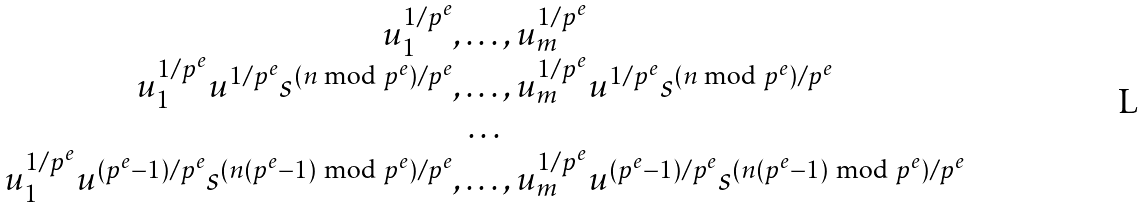Convert formula to latex. <formula><loc_0><loc_0><loc_500><loc_500>\begin{array} { c } u _ { 1 } ^ { 1 / p ^ { e } } , \dots , u _ { m } ^ { 1 / p ^ { e } } \\ u _ { 1 } ^ { 1 / p ^ { e } } u ^ { 1 / p ^ { e } } s ^ { ( n \text { mod } p ^ { e } ) / p ^ { e } } , \dots , u _ { m } ^ { 1 / p ^ { e } } u ^ { 1 / p ^ { e } } s ^ { ( n \text { mod } p ^ { e } ) / p ^ { e } } \\ \dots \\ u _ { 1 } ^ { 1 / p ^ { e } } u ^ { ( p ^ { e } - 1 ) / p ^ { e } } s ^ { ( n ( p ^ { e } - 1 ) \text { mod } p ^ { e } ) / p ^ { e } } , \dots , u _ { m } ^ { 1 / p ^ { e } } u ^ { ( p ^ { e } - 1 ) / p ^ { e } } s ^ { ( n ( p ^ { e } - 1 ) \text { mod } p ^ { e } ) / p ^ { e } } \end{array}</formula> 